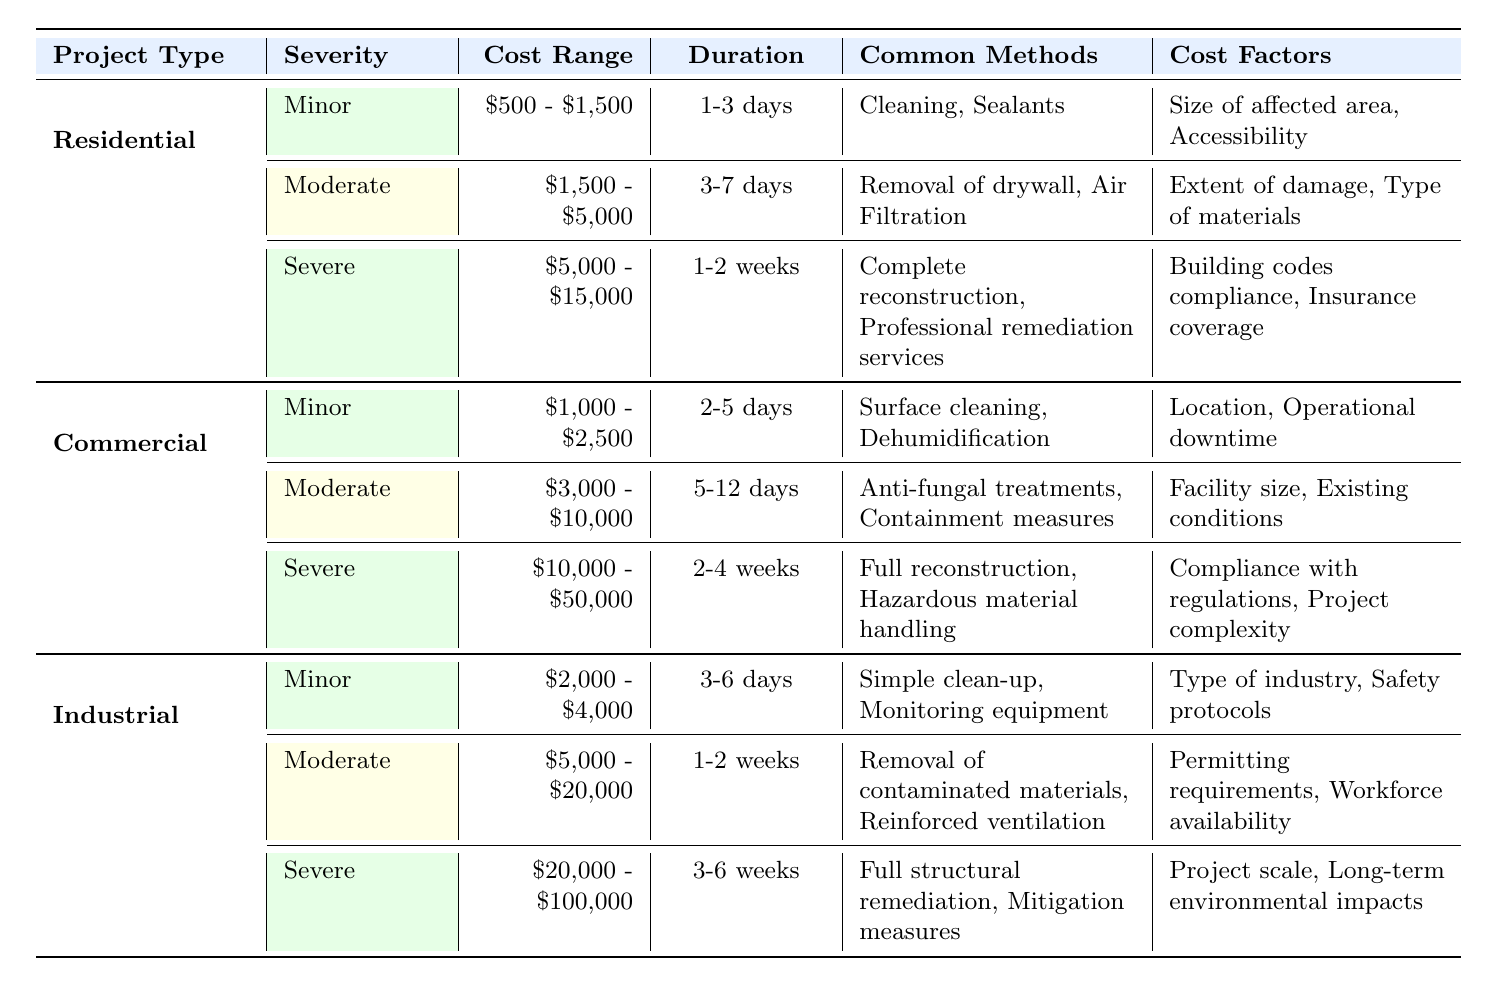What is the cost range for mold remediation of severe infestation in residential projects? The table states the cost range for severe infestation under residential projects is $5,000 - $15,000.
Answer: $5,000 - $15,000 How long does a moderate infestation typically take to remediate in commercial projects? According to the table, the typical duration for a moderate infestation in commercial projects is 5-12 days.
Answer: 5-12 days Is the cost range for severe infestations in industrial projects higher than that of commercial projects? The cost range for severe infestations in industrial projects is $20,000 - $100,000, while for commercial projects, it is $10,000 - $50,000. Thus, the industrial range is higher.
Answer: Yes What common methods are used for minor infestations in residential projects? The table lists the common methods for minor infestations in residential projects as cleaning and sealants.
Answer: Cleaning, Sealants What is the average cost range for mold remediation across all project types for moderate infestations? Moderates infestations' cost ranges are: Residential $1,500 - $5,000, Commercial $3,000 - $10,000, Industrial $5,000 - $20,000. The averages for each are (1500 + 5000)/2 = 3250, (3000 + 10000)/2 = 6500, (5000 + 20000)/2 = 12500. The total average is (3250 + 6500 + 12500) / 3 = 5250.
Answer: $5,250 Is the duration for severe infestations in residential projects less than that in industrial projects? The table shows that the duration for severe infestations in residential projects is 1-2 weeks, and for industrial projects, it is 3-6 weeks. Therefore, the duration in residential projects is less.
Answer: Yes Which project type has the highest cost range for minor infestations? The table indicates that for minor infestations: Residential projects range from $500 - $1,500, Commercial projects from $1,000 - $2,500, and Industrial projects from $2,000 - $4,000. Industrial projects have the highest cost range, from $2,000 - $4,000.
Answer: Industrial Projects What are the factors affecting the cost for severe infestations in commercial projects? The factors listed in the table for severe infestations in commercial projects include compliance with regulations and project complexity.
Answer: Compliance with regulations, Project complexity What is the typical duration for minor infestations in industrial projects? According to the table, the typical duration for minor infestations in industrial projects is 3-6 days.
Answer: 3-6 days 